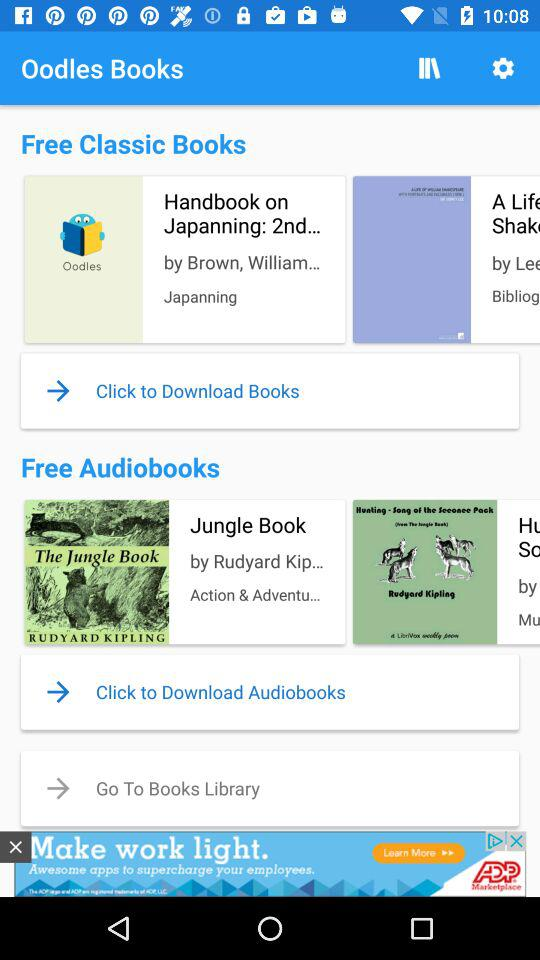Who is the writer of "Handbook on Japanning"? The writer is "Brown, William...". 